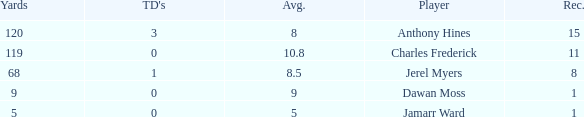What is the typical quantity of tds when the yards amount to less than 119, the avg is greater than 5, and jamarr ward is involved? None. 